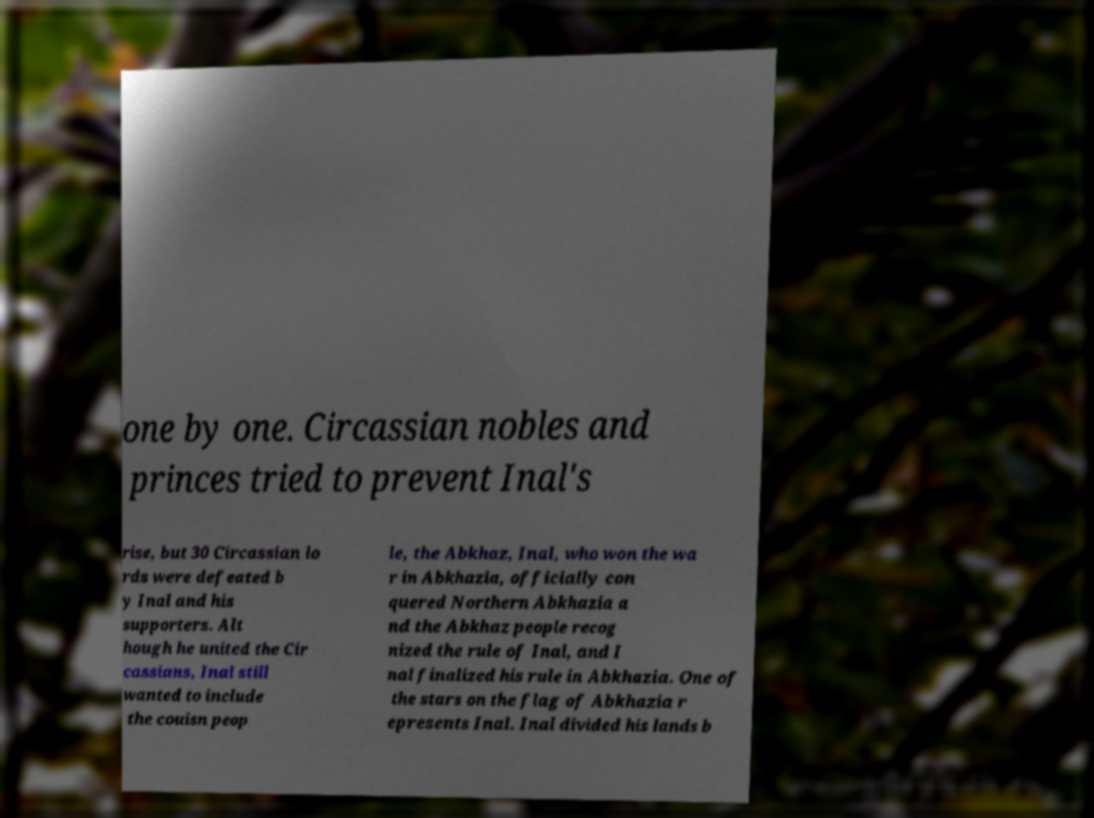Can you read and provide the text displayed in the image?This photo seems to have some interesting text. Can you extract and type it out for me? one by one. Circassian nobles and princes tried to prevent Inal's rise, but 30 Circassian lo rds were defeated b y Inal and his supporters. Alt hough he united the Cir cassians, Inal still wanted to include the couisn peop le, the Abkhaz, Inal, who won the wa r in Abkhazia, officially con quered Northern Abkhazia a nd the Abkhaz people recog nized the rule of Inal, and I nal finalized his rule in Abkhazia. One of the stars on the flag of Abkhazia r epresents Inal. Inal divided his lands b 